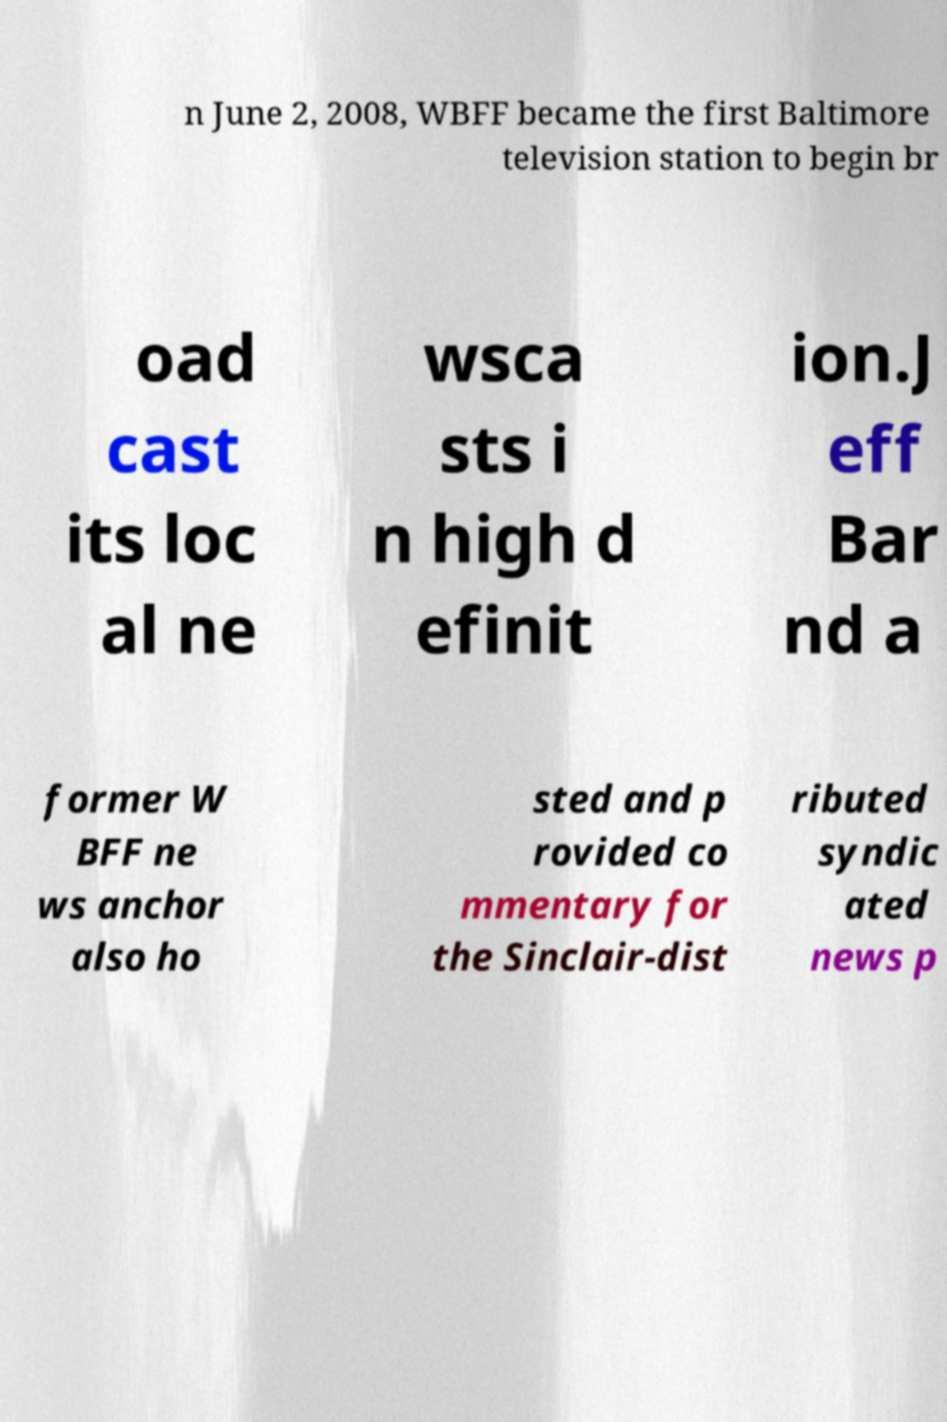I need the written content from this picture converted into text. Can you do that? n June 2, 2008, WBFF became the first Baltimore television station to begin br oad cast its loc al ne wsca sts i n high d efinit ion.J eff Bar nd a former W BFF ne ws anchor also ho sted and p rovided co mmentary for the Sinclair-dist ributed syndic ated news p 